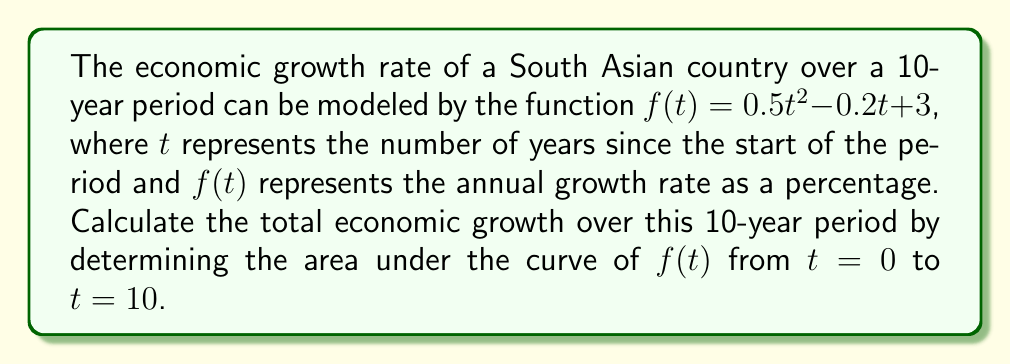Provide a solution to this math problem. To find the area under the curve, we need to integrate the function $f(t)$ from $t=0$ to $t=10$. Let's follow these steps:

1) The integral we need to calculate is:

   $$\int_0^{10} (0.5t^2 - 0.2t + 3) dt$$

2) Integrate each term separately:

   $$\int 0.5t^2 dt = \frac{0.5t^3}{3}$$
   $$\int -0.2t dt = -0.1t^2$$
   $$\int 3 dt = 3t$$

3) Combine these results:

   $$\int (0.5t^2 - 0.2t + 3) dt = \frac{0.5t^3}{3} - 0.1t^2 + 3t + C$$

4) Now, we need to evaluate this from $t=0$ to $t=10$:

   $$[\frac{0.5t^3}{3} - 0.1t^2 + 3t]_0^{10}$$

5) Substitute $t=10$:

   $$\frac{0.5(10^3)}{3} - 0.1(10^2) + 3(10) = \frac{500}{3} - 10 + 30$$

6) Substitute $t=0$:

   $$\frac{0.5(0^3)}{3} - 0.1(0^2) + 3(0) = 0$$

7) Subtract the result of step 6 from step 5:

   $$\frac{500}{3} - 10 + 30 - 0 = \frac{500}{3} + 20 = \frac{560}{3}$$

The result represents the total percentage growth over the 10-year period.
Answer: The total economic growth over the 10-year period is $\frac{560}{3}\%$ or approximately $186.67\%$. 